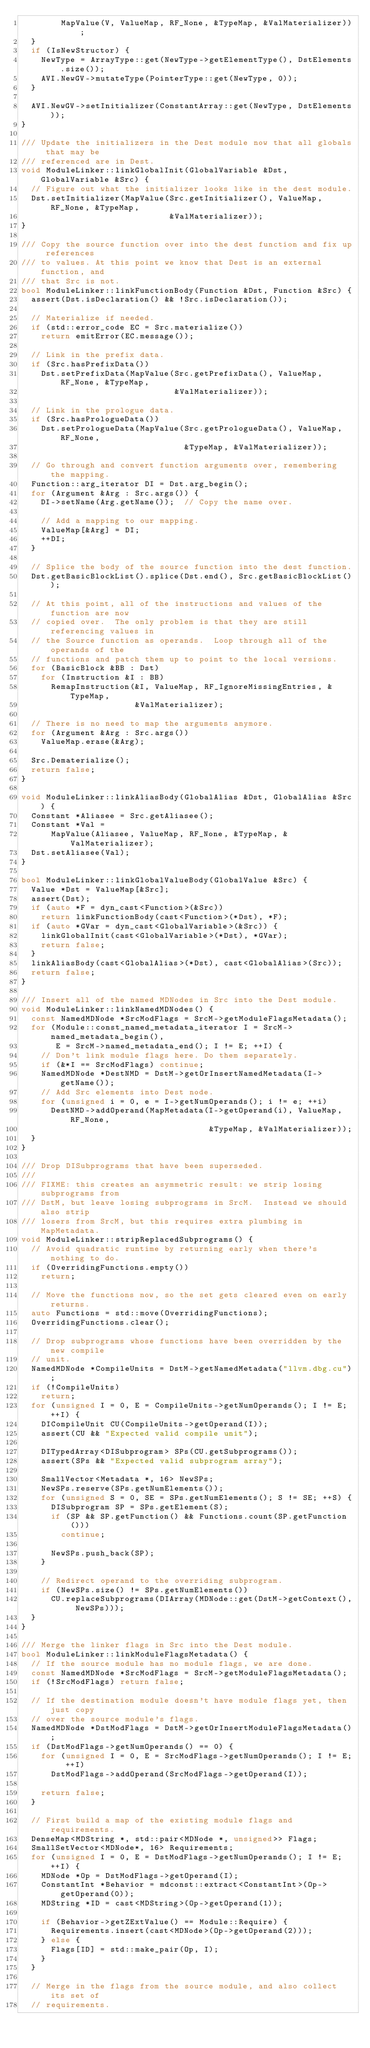Convert code to text. <code><loc_0><loc_0><loc_500><loc_500><_C++_>        MapValue(V, ValueMap, RF_None, &TypeMap, &ValMaterializer));
  }
  if (IsNewStructor) {
    NewType = ArrayType::get(NewType->getElementType(), DstElements.size());
    AVI.NewGV->mutateType(PointerType::get(NewType, 0));
  }

  AVI.NewGV->setInitializer(ConstantArray::get(NewType, DstElements));
}

/// Update the initializers in the Dest module now that all globals that may be
/// referenced are in Dest.
void ModuleLinker::linkGlobalInit(GlobalVariable &Dst, GlobalVariable &Src) {
  // Figure out what the initializer looks like in the dest module.
  Dst.setInitializer(MapValue(Src.getInitializer(), ValueMap, RF_None, &TypeMap,
                              &ValMaterializer));
}

/// Copy the source function over into the dest function and fix up references
/// to values. At this point we know that Dest is an external function, and
/// that Src is not.
bool ModuleLinker::linkFunctionBody(Function &Dst, Function &Src) {
  assert(Dst.isDeclaration() && !Src.isDeclaration());

  // Materialize if needed.
  if (std::error_code EC = Src.materialize())
    return emitError(EC.message());

  // Link in the prefix data.
  if (Src.hasPrefixData())
    Dst.setPrefixData(MapValue(Src.getPrefixData(), ValueMap, RF_None, &TypeMap,
                               &ValMaterializer));

  // Link in the prologue data.
  if (Src.hasPrologueData())
    Dst.setPrologueData(MapValue(Src.getPrologueData(), ValueMap, RF_None,
                                 &TypeMap, &ValMaterializer));

  // Go through and convert function arguments over, remembering the mapping.
  Function::arg_iterator DI = Dst.arg_begin();
  for (Argument &Arg : Src.args()) {
    DI->setName(Arg.getName());  // Copy the name over.

    // Add a mapping to our mapping.
    ValueMap[&Arg] = DI;
    ++DI;
  }

  // Splice the body of the source function into the dest function.
  Dst.getBasicBlockList().splice(Dst.end(), Src.getBasicBlockList());

  // At this point, all of the instructions and values of the function are now
  // copied over.  The only problem is that they are still referencing values in
  // the Source function as operands.  Loop through all of the operands of the
  // functions and patch them up to point to the local versions.
  for (BasicBlock &BB : Dst)
    for (Instruction &I : BB)
      RemapInstruction(&I, ValueMap, RF_IgnoreMissingEntries, &TypeMap,
                       &ValMaterializer);

  // There is no need to map the arguments anymore.
  for (Argument &Arg : Src.args())
    ValueMap.erase(&Arg);

  Src.Dematerialize();
  return false;
}

void ModuleLinker::linkAliasBody(GlobalAlias &Dst, GlobalAlias &Src) {
  Constant *Aliasee = Src.getAliasee();
  Constant *Val =
      MapValue(Aliasee, ValueMap, RF_None, &TypeMap, &ValMaterializer);
  Dst.setAliasee(Val);
}

bool ModuleLinker::linkGlobalValueBody(GlobalValue &Src) {
  Value *Dst = ValueMap[&Src];
  assert(Dst);
  if (auto *F = dyn_cast<Function>(&Src))
    return linkFunctionBody(cast<Function>(*Dst), *F);
  if (auto *GVar = dyn_cast<GlobalVariable>(&Src)) {
    linkGlobalInit(cast<GlobalVariable>(*Dst), *GVar);
    return false;
  }
  linkAliasBody(cast<GlobalAlias>(*Dst), cast<GlobalAlias>(Src));
  return false;
}

/// Insert all of the named MDNodes in Src into the Dest module.
void ModuleLinker::linkNamedMDNodes() {
  const NamedMDNode *SrcModFlags = SrcM->getModuleFlagsMetadata();
  for (Module::const_named_metadata_iterator I = SrcM->named_metadata_begin(),
       E = SrcM->named_metadata_end(); I != E; ++I) {
    // Don't link module flags here. Do them separately.
    if (&*I == SrcModFlags) continue;
    NamedMDNode *DestNMD = DstM->getOrInsertNamedMetadata(I->getName());
    // Add Src elements into Dest node.
    for (unsigned i = 0, e = I->getNumOperands(); i != e; ++i)
      DestNMD->addOperand(MapMetadata(I->getOperand(i), ValueMap, RF_None,
                                      &TypeMap, &ValMaterializer));
  }
}

/// Drop DISubprograms that have been superseded.
///
/// FIXME: this creates an asymmetric result: we strip losing subprograms from
/// DstM, but leave losing subprograms in SrcM.  Instead we should also strip
/// losers from SrcM, but this requires extra plumbing in MapMetadata.
void ModuleLinker::stripReplacedSubprograms() {
  // Avoid quadratic runtime by returning early when there's nothing to do.
  if (OverridingFunctions.empty())
    return;

  // Move the functions now, so the set gets cleared even on early returns.
  auto Functions = std::move(OverridingFunctions);
  OverridingFunctions.clear();

  // Drop subprograms whose functions have been overridden by the new compile
  // unit.
  NamedMDNode *CompileUnits = DstM->getNamedMetadata("llvm.dbg.cu");
  if (!CompileUnits)
    return;
  for (unsigned I = 0, E = CompileUnits->getNumOperands(); I != E; ++I) {
    DICompileUnit CU(CompileUnits->getOperand(I));
    assert(CU && "Expected valid compile unit");

    DITypedArray<DISubprogram> SPs(CU.getSubprograms());
    assert(SPs && "Expected valid subprogram array");

    SmallVector<Metadata *, 16> NewSPs;
    NewSPs.reserve(SPs.getNumElements());
    for (unsigned S = 0, SE = SPs.getNumElements(); S != SE; ++S) {
      DISubprogram SP = SPs.getElement(S);
      if (SP && SP.getFunction() && Functions.count(SP.getFunction()))
        continue;

      NewSPs.push_back(SP);
    }

    // Redirect operand to the overriding subprogram.
    if (NewSPs.size() != SPs.getNumElements())
      CU.replaceSubprograms(DIArray(MDNode::get(DstM->getContext(), NewSPs)));
  }
}

/// Merge the linker flags in Src into the Dest module.
bool ModuleLinker::linkModuleFlagsMetadata() {
  // If the source module has no module flags, we are done.
  const NamedMDNode *SrcModFlags = SrcM->getModuleFlagsMetadata();
  if (!SrcModFlags) return false;

  // If the destination module doesn't have module flags yet, then just copy
  // over the source module's flags.
  NamedMDNode *DstModFlags = DstM->getOrInsertModuleFlagsMetadata();
  if (DstModFlags->getNumOperands() == 0) {
    for (unsigned I = 0, E = SrcModFlags->getNumOperands(); I != E; ++I)
      DstModFlags->addOperand(SrcModFlags->getOperand(I));

    return false;
  }

  // First build a map of the existing module flags and requirements.
  DenseMap<MDString *, std::pair<MDNode *, unsigned>> Flags;
  SmallSetVector<MDNode*, 16> Requirements;
  for (unsigned I = 0, E = DstModFlags->getNumOperands(); I != E; ++I) {
    MDNode *Op = DstModFlags->getOperand(I);
    ConstantInt *Behavior = mdconst::extract<ConstantInt>(Op->getOperand(0));
    MDString *ID = cast<MDString>(Op->getOperand(1));

    if (Behavior->getZExtValue() == Module::Require) {
      Requirements.insert(cast<MDNode>(Op->getOperand(2)));
    } else {
      Flags[ID] = std::make_pair(Op, I);
    }
  }

  // Merge in the flags from the source module, and also collect its set of
  // requirements.</code> 